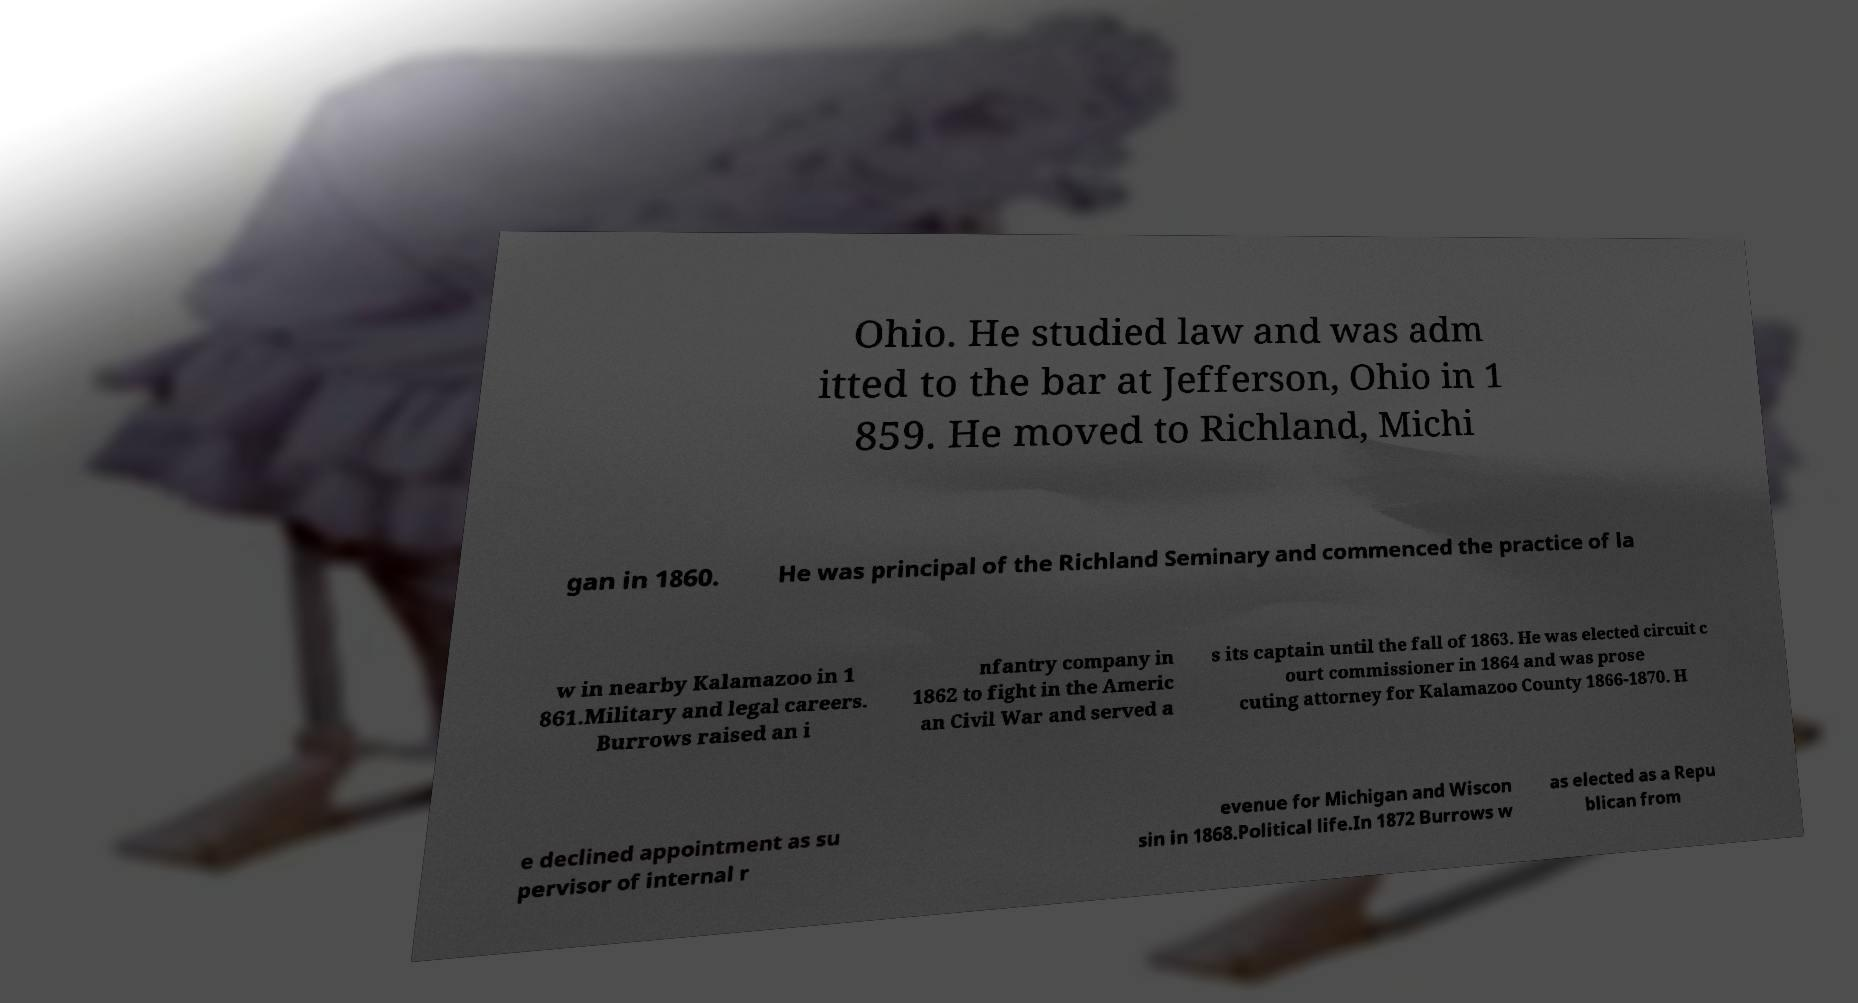Could you extract and type out the text from this image? Ohio. He studied law and was adm itted to the bar at Jefferson, Ohio in 1 859. He moved to Richland, Michi gan in 1860. He was principal of the Richland Seminary and commenced the practice of la w in nearby Kalamazoo in 1 861.Military and legal careers. Burrows raised an i nfantry company in 1862 to fight in the Americ an Civil War and served a s its captain until the fall of 1863. He was elected circuit c ourt commissioner in 1864 and was prose cuting attorney for Kalamazoo County 1866-1870. H e declined appointment as su pervisor of internal r evenue for Michigan and Wiscon sin in 1868.Political life.In 1872 Burrows w as elected as a Repu blican from 